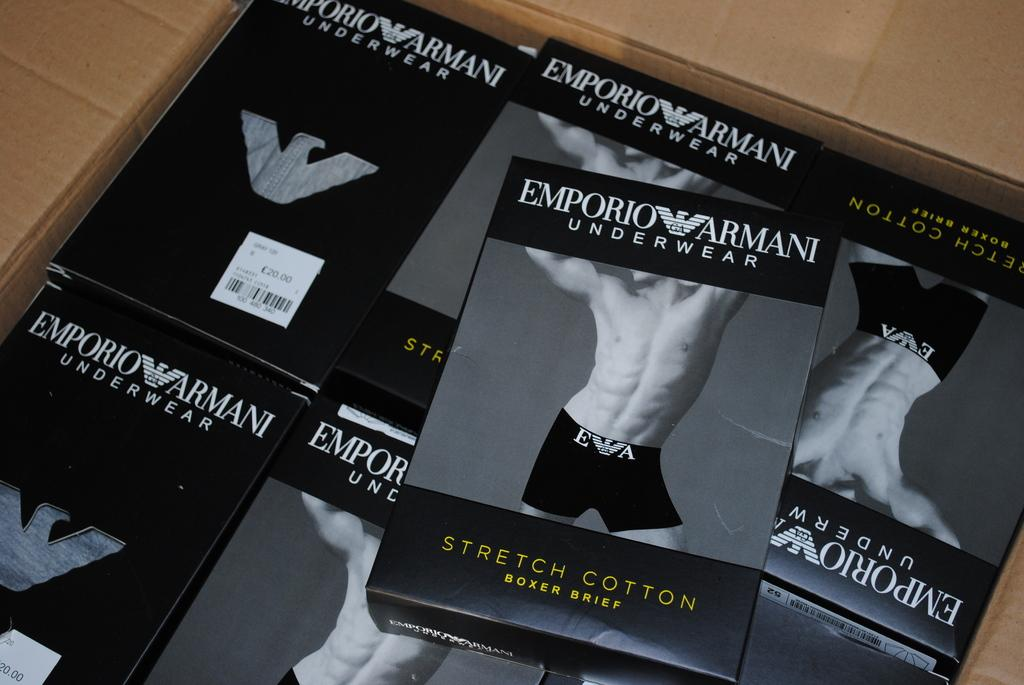<image>
Share a concise interpretation of the image provided. A collection of Emporio Armani underwear in a brown box. 